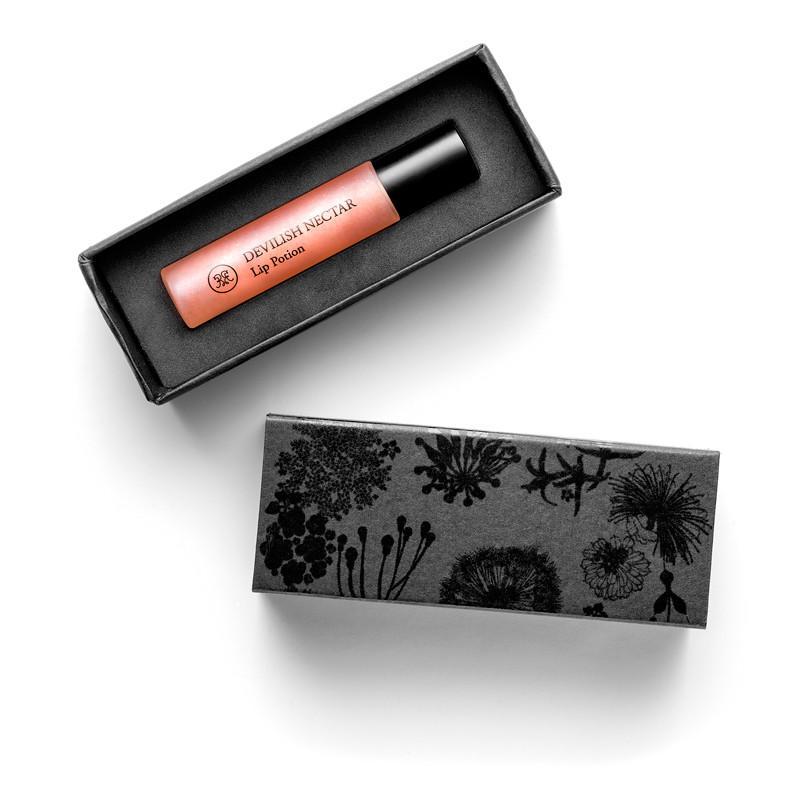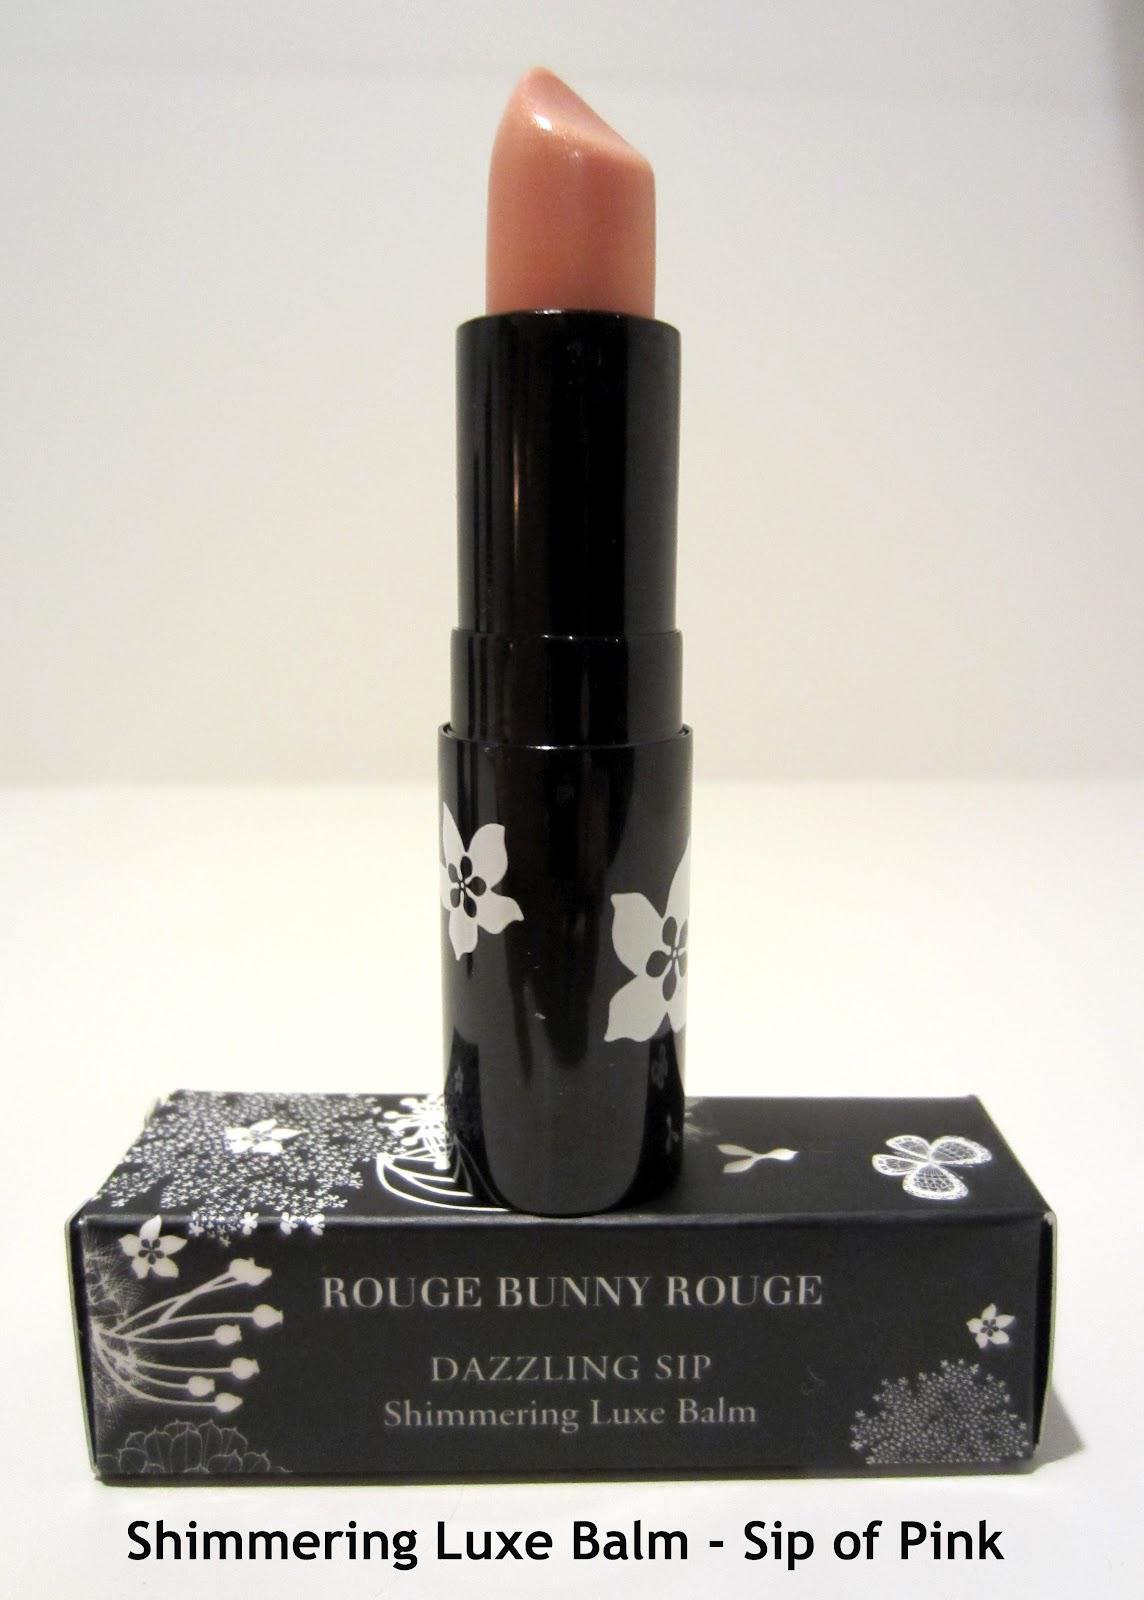The first image is the image on the left, the second image is the image on the right. For the images shown, is this caption "there is no more then one lipstick visible in the right side pic" true? Answer yes or no. Yes. The first image is the image on the left, the second image is the image on the right. Evaluate the accuracy of this statement regarding the images: "Lip applicants are displayed in a line of 11 or more.". Is it true? Answer yes or no. No. 